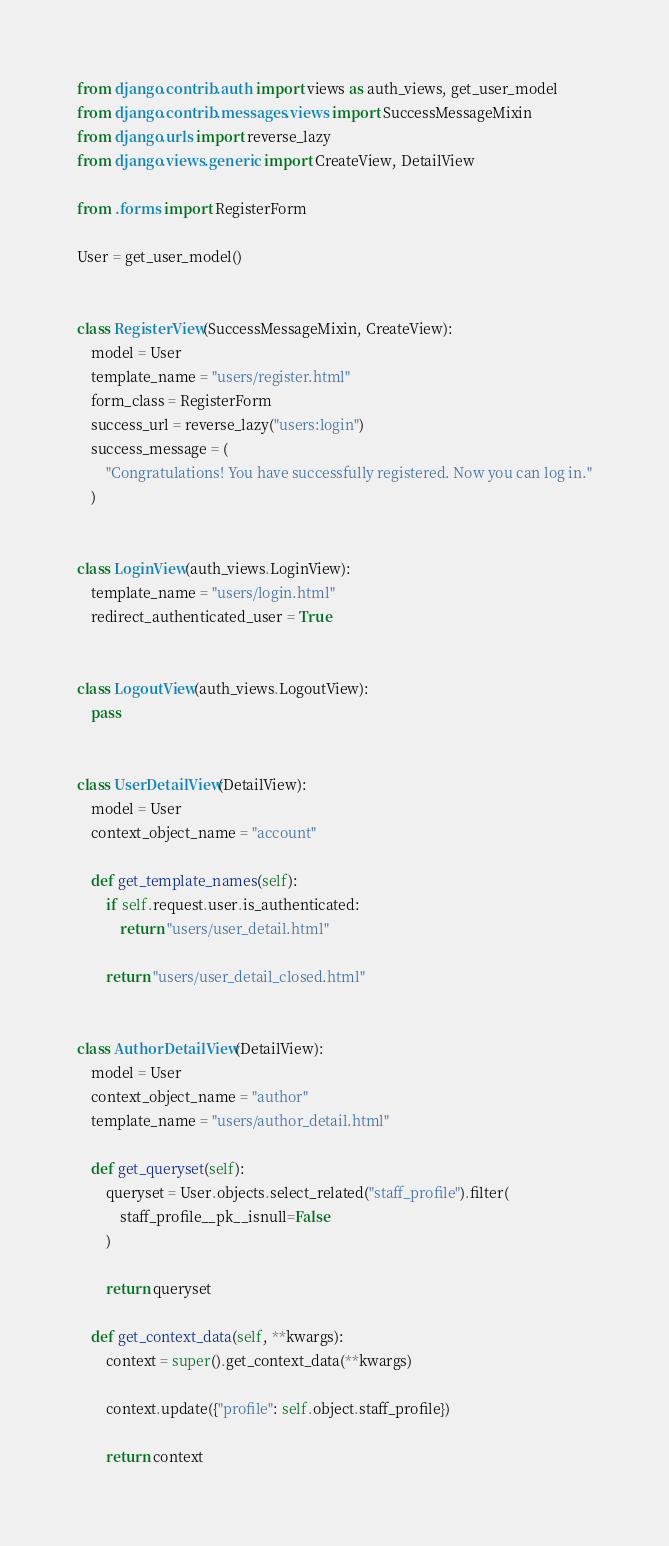<code> <loc_0><loc_0><loc_500><loc_500><_Python_>from django.contrib.auth import views as auth_views, get_user_model
from django.contrib.messages.views import SuccessMessageMixin
from django.urls import reverse_lazy
from django.views.generic import CreateView, DetailView

from .forms import RegisterForm

User = get_user_model()


class RegisterView(SuccessMessageMixin, CreateView):
    model = User
    template_name = "users/register.html"
    form_class = RegisterForm
    success_url = reverse_lazy("users:login")
    success_message = (
        "Congratulations! You have successfully registered. Now you can log in."
    )


class LoginView(auth_views.LoginView):
    template_name = "users/login.html"
    redirect_authenticated_user = True


class LogoutView(auth_views.LogoutView):
    pass


class UserDetailView(DetailView):
    model = User
    context_object_name = "account"

    def get_template_names(self):
        if self.request.user.is_authenticated:
            return "users/user_detail.html"

        return "users/user_detail_closed.html"


class AuthorDetailView(DetailView):
    model = User
    context_object_name = "author"
    template_name = "users/author_detail.html"

    def get_queryset(self):
        queryset = User.objects.select_related("staff_profile").filter(
            staff_profile__pk__isnull=False
        )

        return queryset

    def get_context_data(self, **kwargs):
        context = super().get_context_data(**kwargs)

        context.update({"profile": self.object.staff_profile})

        return context
</code> 